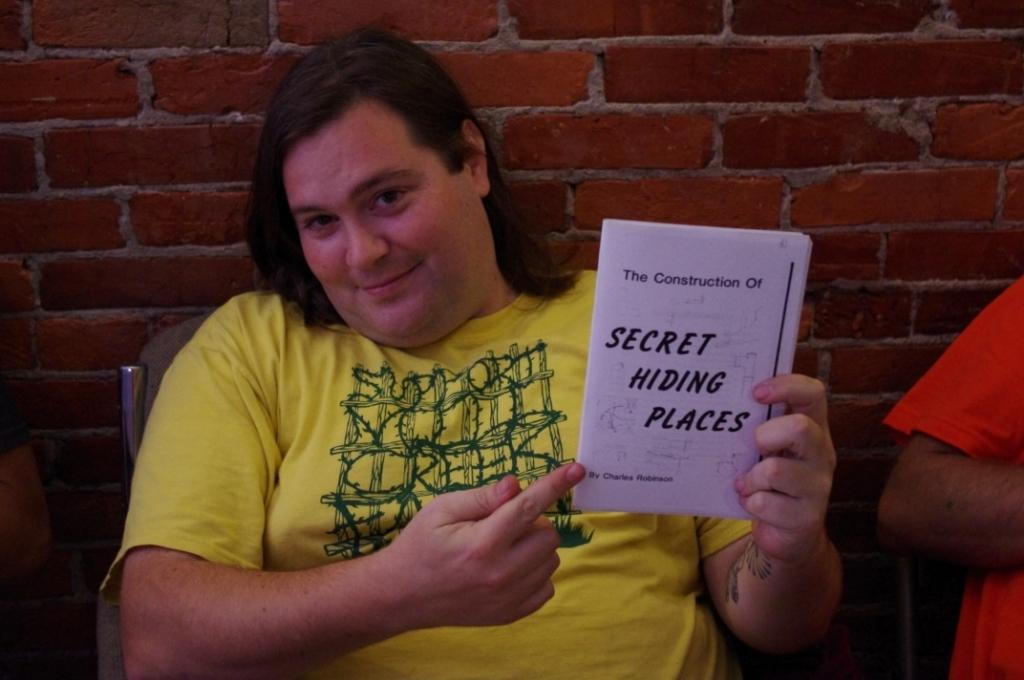Provide a one-sentence caption for the provided image. A person in a yellow shirt is holding a white booklet that reads Secret Hiding Places. 